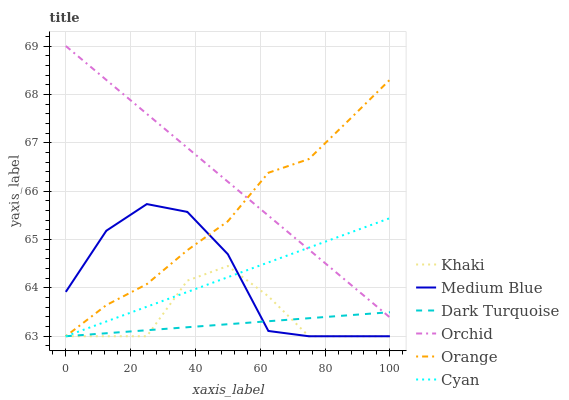Does Medium Blue have the minimum area under the curve?
Answer yes or no. No. Does Medium Blue have the maximum area under the curve?
Answer yes or no. No. Is Dark Turquoise the smoothest?
Answer yes or no. No. Is Dark Turquoise the roughest?
Answer yes or no. No. Does Orchid have the lowest value?
Answer yes or no. No. Does Medium Blue have the highest value?
Answer yes or no. No. Is Khaki less than Orchid?
Answer yes or no. Yes. Is Orchid greater than Medium Blue?
Answer yes or no. Yes. Does Khaki intersect Orchid?
Answer yes or no. No. 